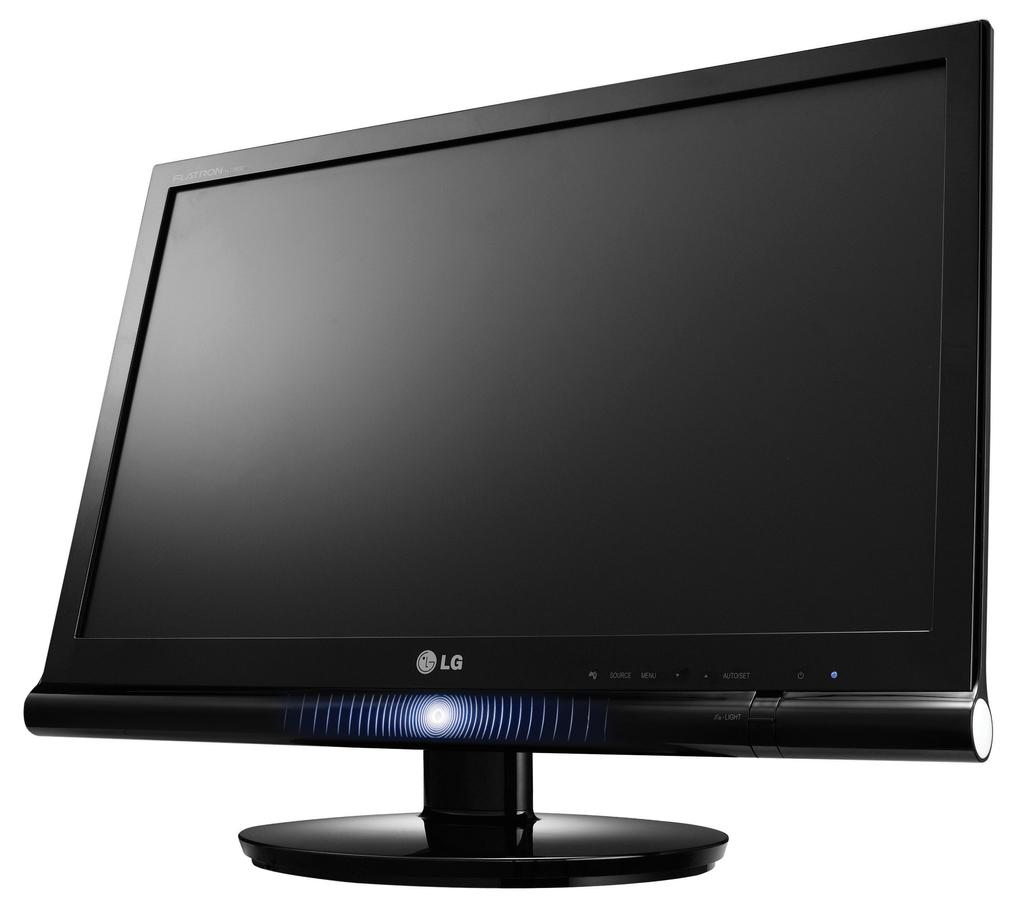<image>
Summarize the visual content of the image. A black LG monitor with a white background. 